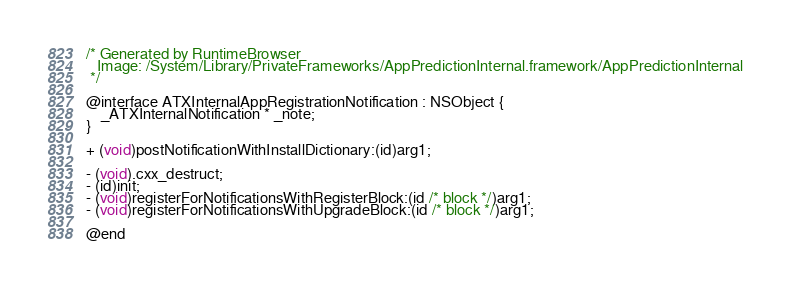Convert code to text. <code><loc_0><loc_0><loc_500><loc_500><_C_>/* Generated by RuntimeBrowser
   Image: /System/Library/PrivateFrameworks/AppPredictionInternal.framework/AppPredictionInternal
 */

@interface ATXInternalAppRegistrationNotification : NSObject {
    _ATXInternalNotification * _note;
}

+ (void)postNotificationWithInstallDictionary:(id)arg1;

- (void).cxx_destruct;
- (id)init;
- (void)registerForNotificationsWithRegisterBlock:(id /* block */)arg1;
- (void)registerForNotificationsWithUpgradeBlock:(id /* block */)arg1;

@end
</code> 